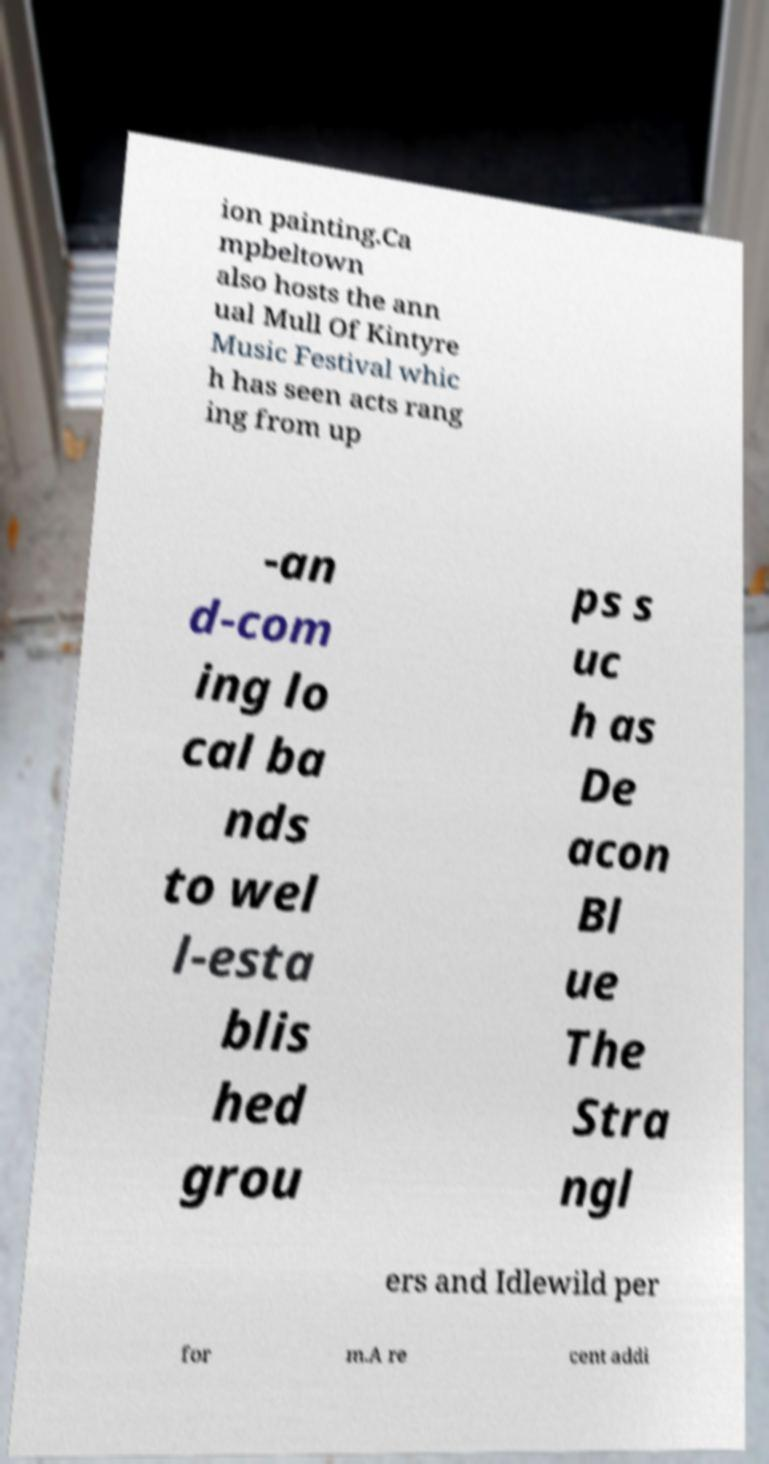I need the written content from this picture converted into text. Can you do that? ion painting.Ca mpbeltown also hosts the ann ual Mull Of Kintyre Music Festival whic h has seen acts rang ing from up -an d-com ing lo cal ba nds to wel l-esta blis hed grou ps s uc h as De acon Bl ue The Stra ngl ers and Idlewild per for m.A re cent addi 